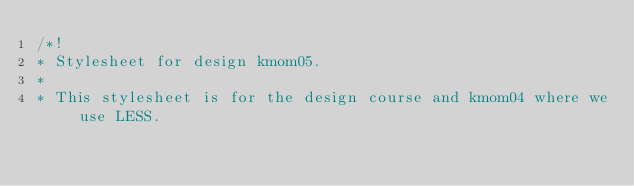<code> <loc_0><loc_0><loc_500><loc_500><_CSS_>/*!
* Stylesheet for design kmom05.
*
* This stylesheet is for the design course and kmom04 where we use LESS.</code> 